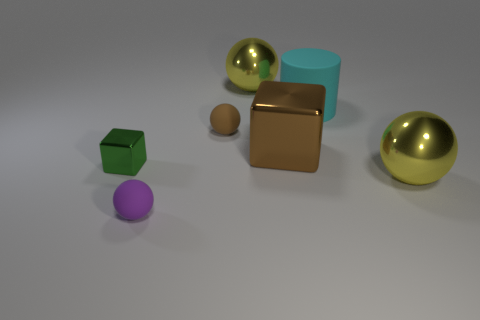Add 2 tiny spheres. How many objects exist? 9 Subtract all small brown balls. How many balls are left? 3 Subtract all cylinders. How many objects are left? 6 Add 3 tiny cyan matte blocks. How many tiny cyan matte blocks exist? 3 Subtract all yellow balls. How many balls are left? 2 Subtract 0 red cylinders. How many objects are left? 7 Subtract 1 cubes. How many cubes are left? 1 Subtract all yellow cylinders. Subtract all brown blocks. How many cylinders are left? 1 Subtract all cyan cubes. How many green spheres are left? 0 Subtract all big purple metal cylinders. Subtract all shiny objects. How many objects are left? 3 